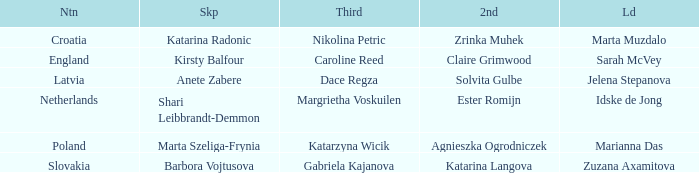What is the name of the third who has Barbora Vojtusova as Skip? Gabriela Kajanova. 